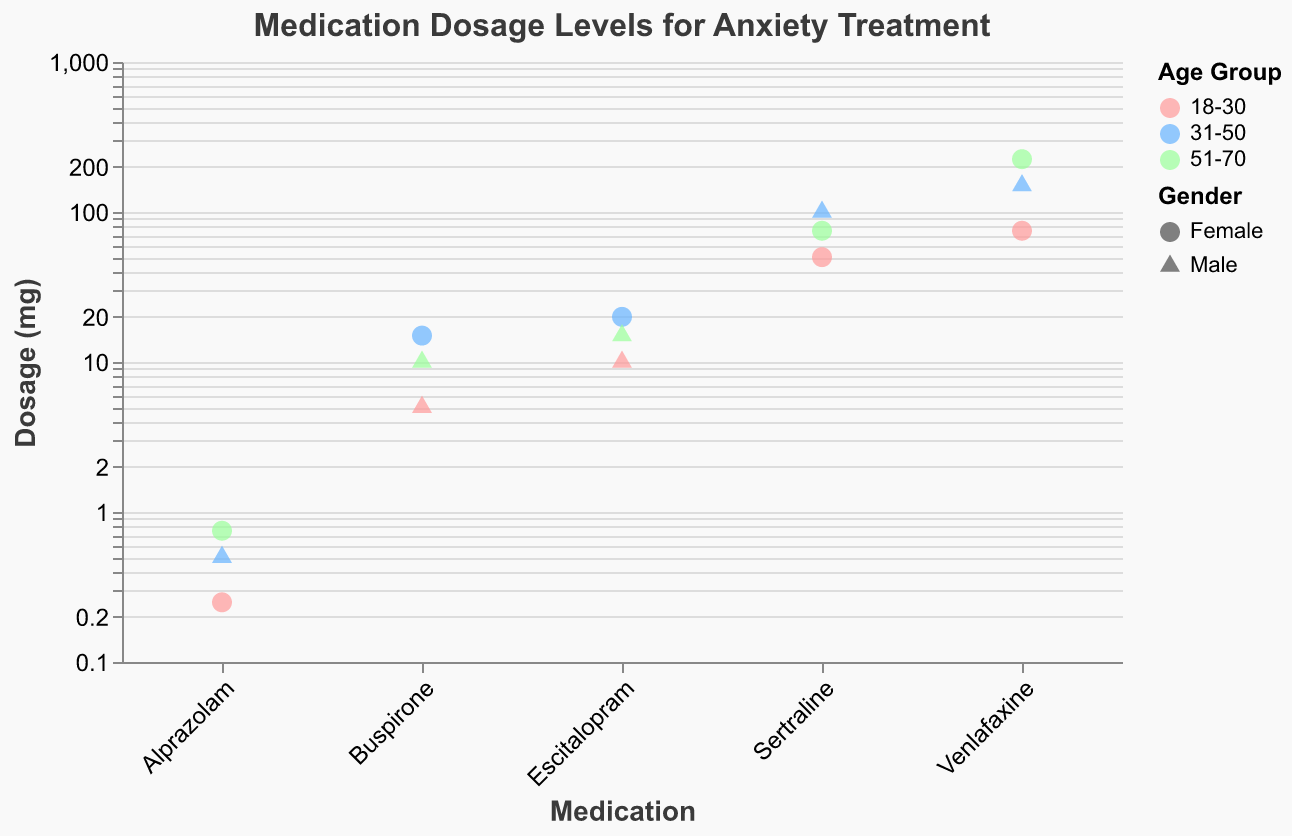What is the title of the figure? The title of a figure is usually found at the top and describes the main subject of the visualization. Here, it specifies "Medication Dosage Levels for Anxiety Treatment".
Answer: Medication Dosage Levels for Anxiety Treatment What are the different age groups represented in the figure? Different age groups are distinguished by different colors in the plot, and the legend indicates these categories. The age groups are "18-30", "31-50", and "51-70".
Answer: 18-30, 31-50, 51-70 Which medication has the highest dosage level for the age group 31-50? Look for the highest point among the data points colored in light blue (represents the age group 31-50) and then check the medication name associated with that point. The highest value in this age group is for Venlafaxine with a dosage of 150 mg.
Answer: Venlafaxine How do the dosages of Sertraline compare across different age groups? Observe the data points corresponding to Sertraline medication and note the dosages for each age group. The dosages for Sertraline are 50 mg for 18-30 (pink), 100 mg for 31-50 (light blue), and 75 mg for 51-70 (green).
Answer: 50 mg for 18-30, 100 mg for 31-50, 75 mg for 51-70 Which gender has a higher dosage of Venlafaxine for the age group 51-70? Look for the point that represents Venlafaxine with a green color (51-70 age group). Note the shape of the point, which indicates the gender. The highest dosage (225 mg) is marked with a circle, indicating female.
Answer: Female Calculate the average dosage of Buspirone for all age groups. Locate all data points for Buspirone and note their dosages: 5 mg, 15 mg, and 10 mg. Sum these values and then divide by the number of points: (5 + 15 + 10) / 3 = 10 mg.
Answer: 10 mg Compare the gender representation for Alprazolam across different age groups. Observe the data points for Alprazolam and note the shapes representing genders: for 18-30 (circle for female), 31-50 (triangle for male), and 51-70 (circle for female).
Answer: Female for 18-30, Male for 31-50, Female for 51-70 What shapes are used to represent different genders in the plot? Check the legend for the gender attribute. It shows that circles are used for females and triangles are used for males.
Answer: Circles for females, triangles for males Identify the medication with the lowest overall dosage level and specify the value. Find the lowest point on the y-axis regardless of medication type. The lowest dosage is for Alprazolam at 0.25 mg.
Answer: Alprazolam, 0.25 mg 